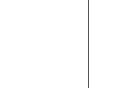<code> <loc_0><loc_0><loc_500><loc_500><_Swift_>
</code> 